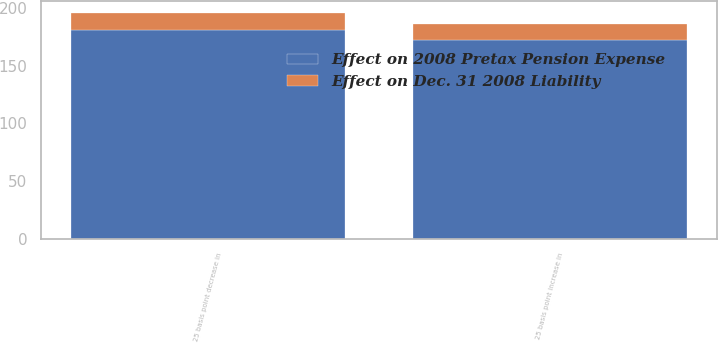Convert chart to OTSL. <chart><loc_0><loc_0><loc_500><loc_500><stacked_bar_chart><ecel><fcel>25 basis point decrease in<fcel>25 basis point increase in<nl><fcel>Effect on Dec. 31 2008 Liability<fcel>15<fcel>14<nl><fcel>Effect on 2008 Pretax Pension Expense<fcel>181<fcel>172<nl></chart> 